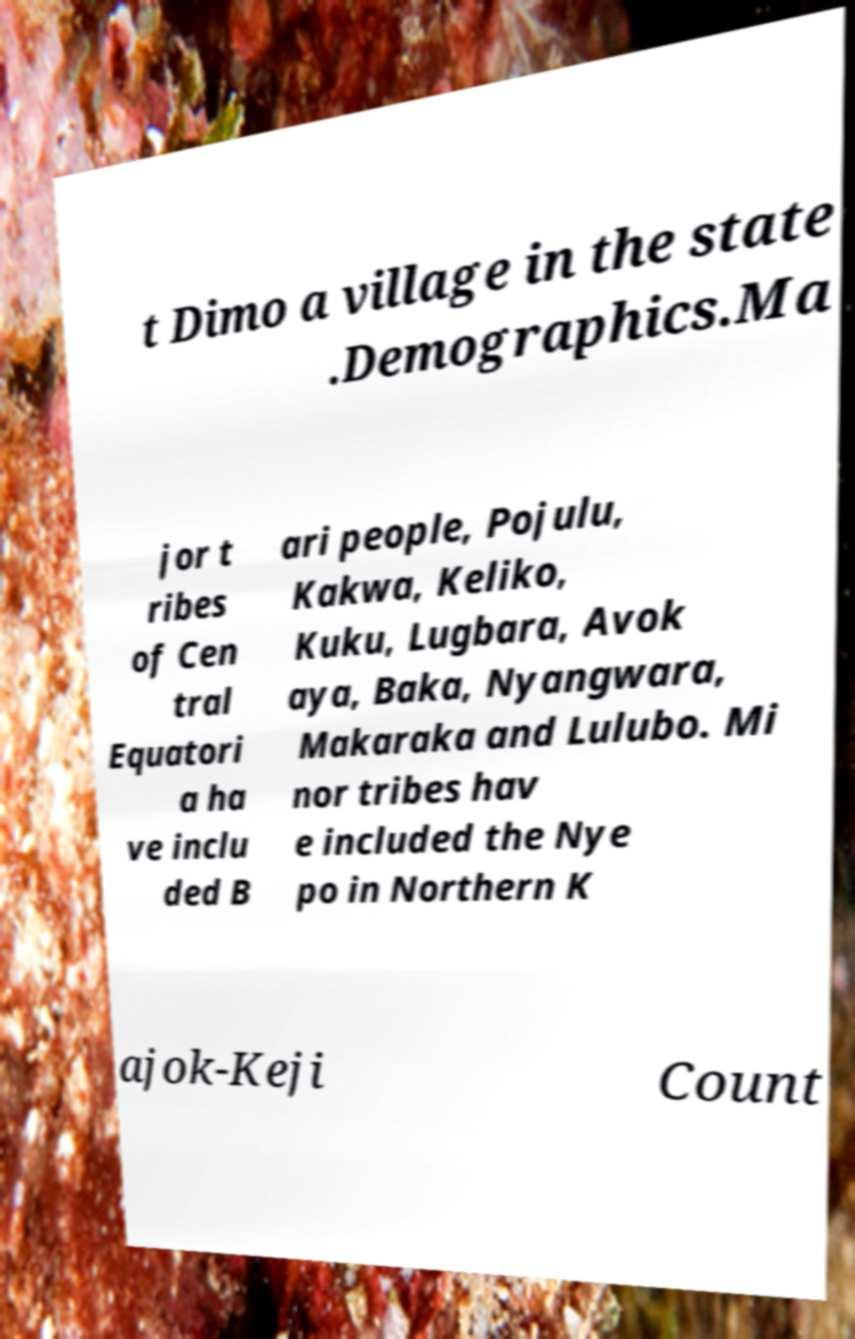Please identify and transcribe the text found in this image. t Dimo a village in the state .Demographics.Ma jor t ribes of Cen tral Equatori a ha ve inclu ded B ari people, Pojulu, Kakwa, Keliko, Kuku, Lugbara, Avok aya, Baka, Nyangwara, Makaraka and Lulubo. Mi nor tribes hav e included the Nye po in Northern K ajok-Keji Count 